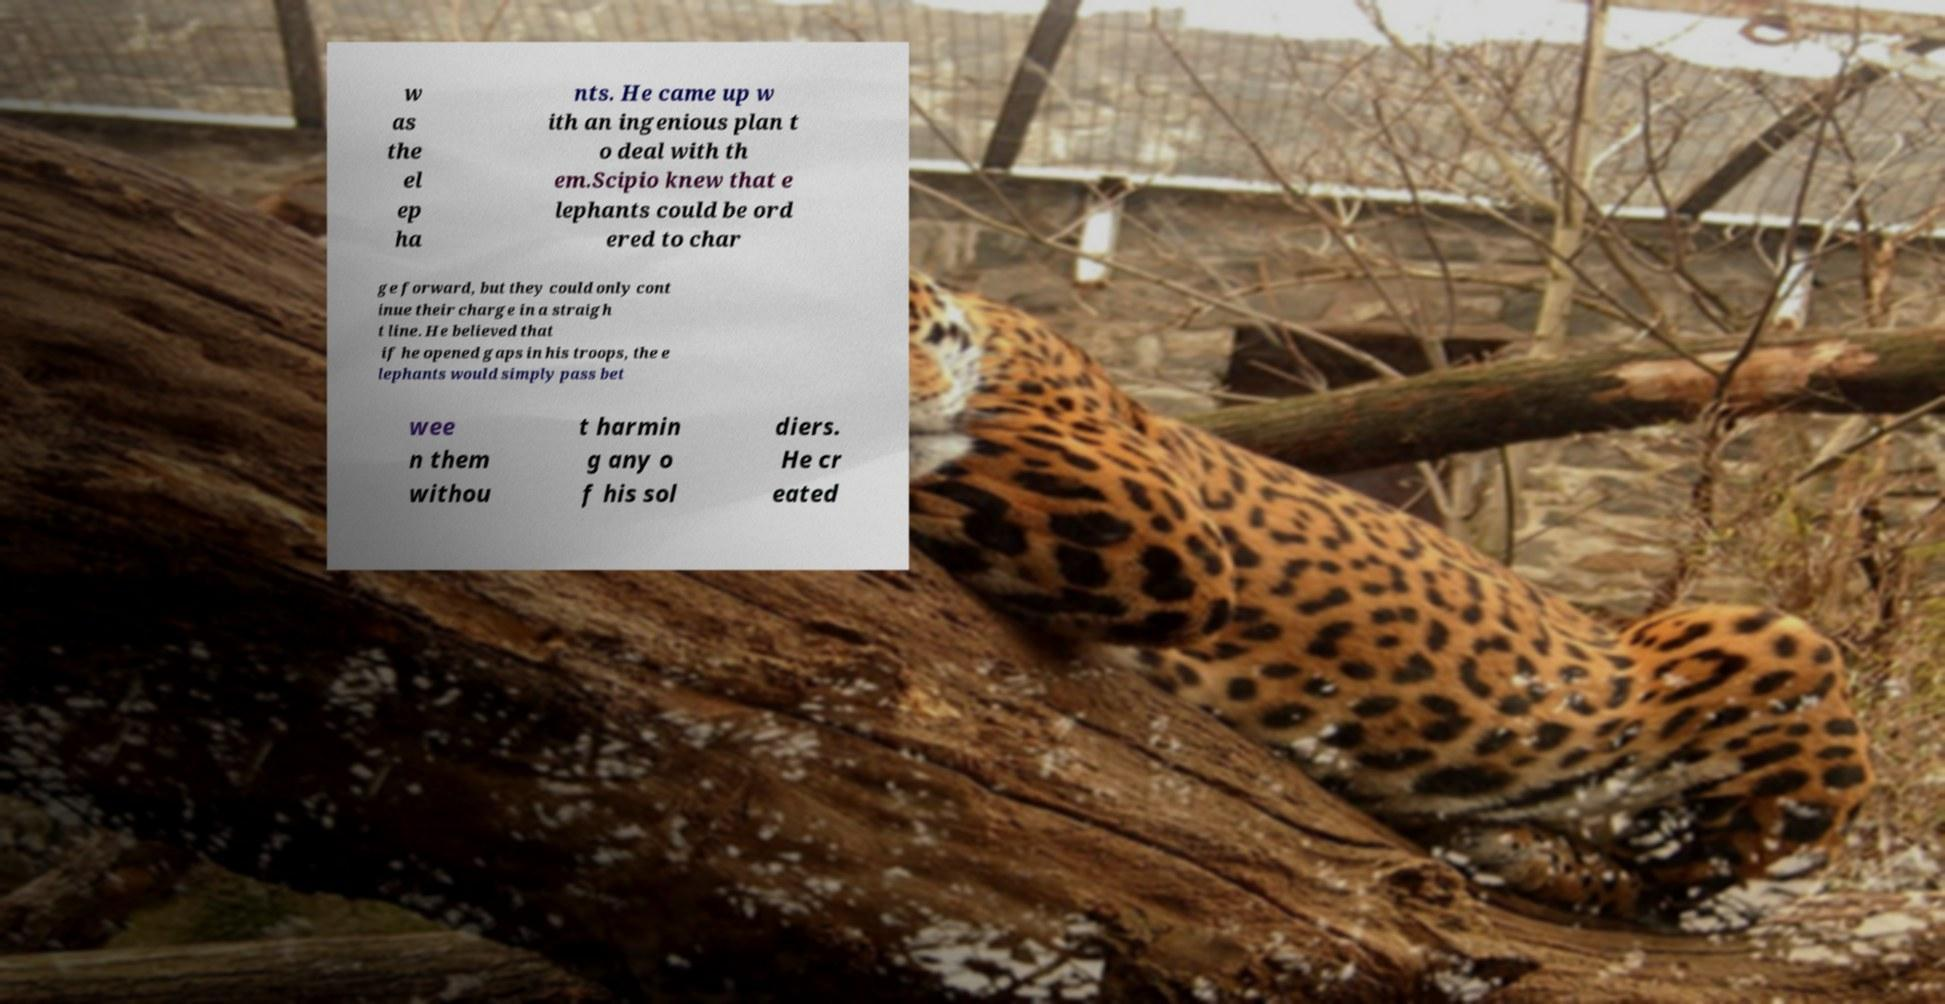Please read and relay the text visible in this image. What does it say? w as the el ep ha nts. He came up w ith an ingenious plan t o deal with th em.Scipio knew that e lephants could be ord ered to char ge forward, but they could only cont inue their charge in a straigh t line. He believed that if he opened gaps in his troops, the e lephants would simply pass bet wee n them withou t harmin g any o f his sol diers. He cr eated 